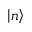Convert formula to latex. <formula><loc_0><loc_0><loc_500><loc_500>\left | n \right ></formula> 